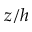Convert formula to latex. <formula><loc_0><loc_0><loc_500><loc_500>z / h</formula> 